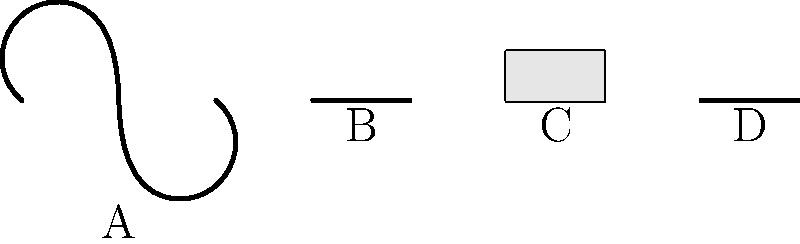In the illustration above, which labeled instrument is commonly used for auscultation in physical examinations? To answer this question, let's consider each instrument and its primary function:

1. Instrument A: This is a stethoscope. It is the primary tool used for auscultation, which is the act of listening to internal sounds of the body, particularly the heart and lungs.

2. Instrument B: This appears to be a scalpel, which is used for making incisions during surgical procedures.

3. Instrument C: This is a syringe, typically used for injecting medications or drawing blood samples.

4. Instrument D: This simple straight line likely represents a thermometer, used for measuring body temperature.

Among these instruments, only the stethoscope (Instrument A) is specifically designed and commonly used for auscultation. It allows medical professionals to listen to heart sounds, lung sounds, and other internal body sounds during physical examinations.
Answer: A 